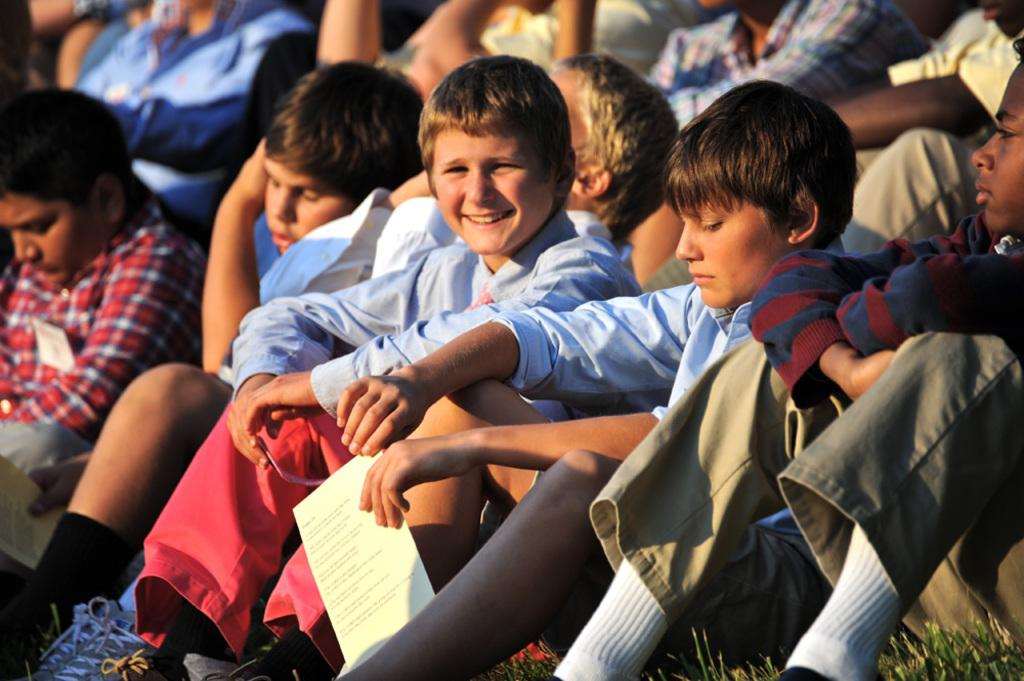How many people are in the image? There are a few people in the image. What can be seen beneath the people in the image? The ground is visible in the image. What type of vegetation is present on the ground? There is grass on the ground. What type of cork can be seen in the image? There is no cork present in the image. 